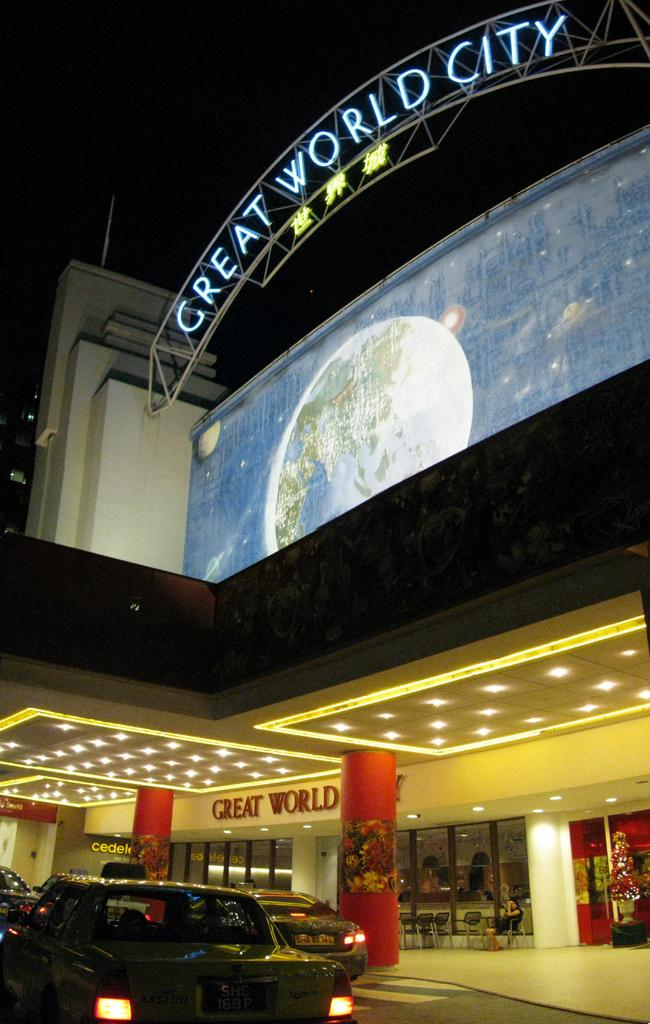What is the main structure in the middle of the image? There is a mall in the middle of the image. What is located at the top of the image? There is a hoarding at the top of the image. What can be seen at the bottom of the image? There are cars on the road at the bottom of the image. What feature is present at the entrance of the mall? There are lights at the entrance of the mall. What type of magic is being performed at the desk in the image? There is no desk or magic performance present in the image. What type of apparel is being sold at the mall in the image? The provided facts do not specify the type of apparel being sold at the mall; we can only confirm that there is a mall in the image. 